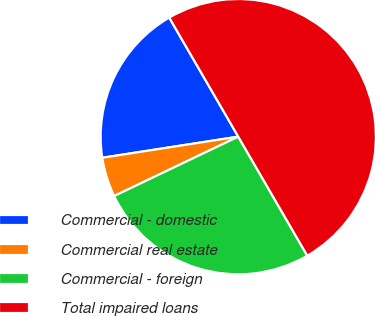Convert chart. <chart><loc_0><loc_0><loc_500><loc_500><pie_chart><fcel>Commercial - domestic<fcel>Commercial real estate<fcel>Commercial - foreign<fcel>Total impaired loans<nl><fcel>19.09%<fcel>4.65%<fcel>26.26%<fcel>50.0%<nl></chart> 